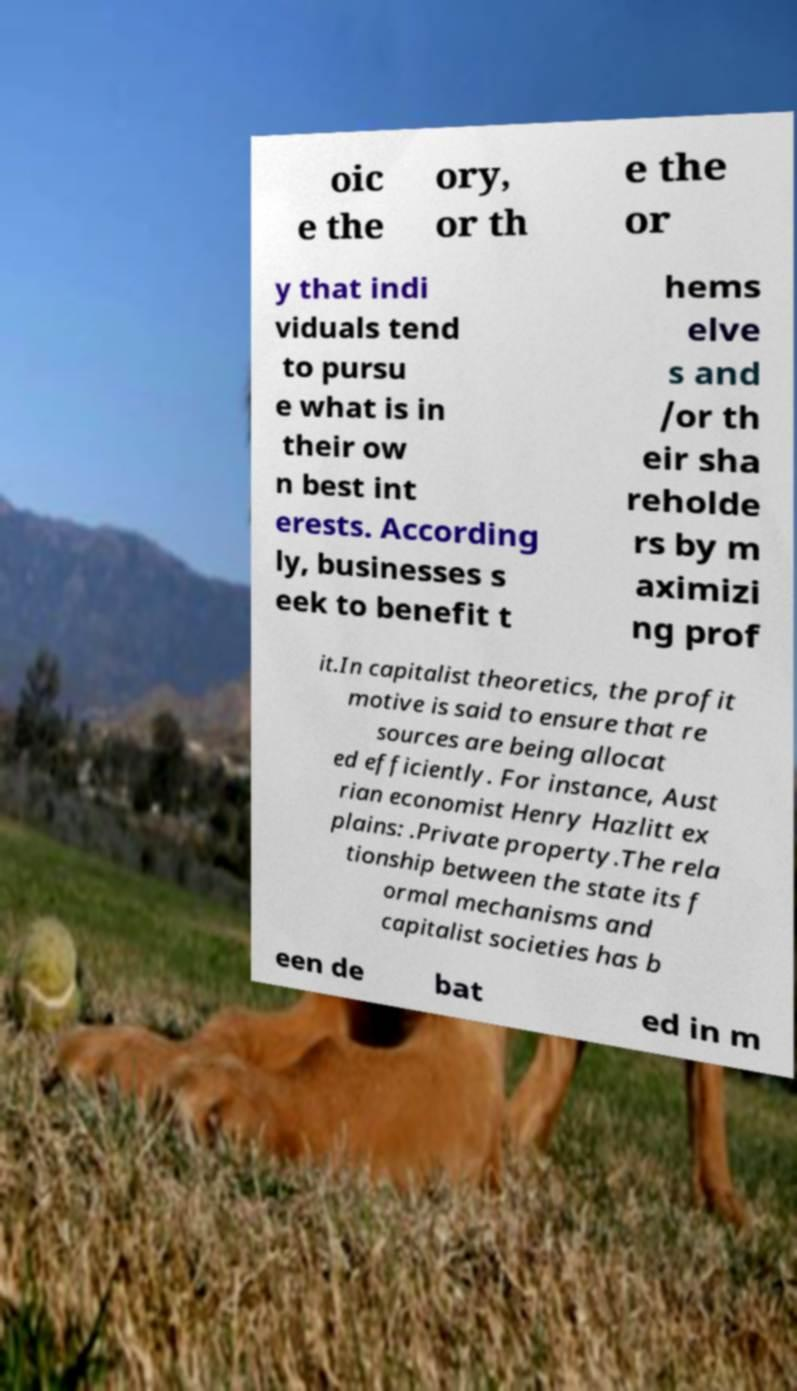Could you extract and type out the text from this image? oic e the ory, or th e the or y that indi viduals tend to pursu e what is in their ow n best int erests. According ly, businesses s eek to benefit t hems elve s and /or th eir sha reholde rs by m aximizi ng prof it.In capitalist theoretics, the profit motive is said to ensure that re sources are being allocat ed efficiently. For instance, Aust rian economist Henry Hazlitt ex plains: .Private property.The rela tionship between the state its f ormal mechanisms and capitalist societies has b een de bat ed in m 